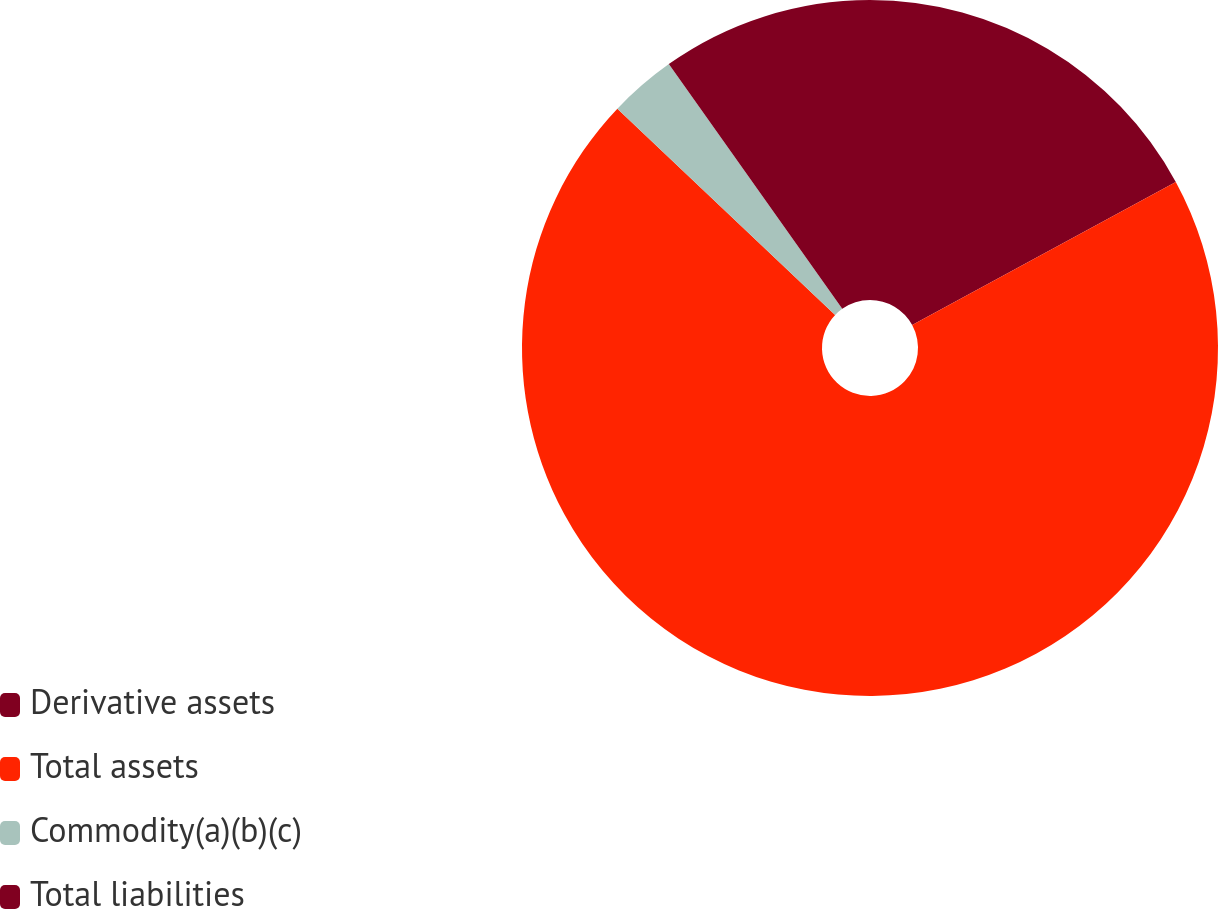Convert chart to OTSL. <chart><loc_0><loc_0><loc_500><loc_500><pie_chart><fcel>Derivative assets<fcel>Total assets<fcel>Commodity(a)(b)(c)<fcel>Total liabilities<nl><fcel>17.08%<fcel>69.99%<fcel>3.12%<fcel>9.81%<nl></chart> 